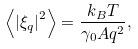Convert formula to latex. <formula><loc_0><loc_0><loc_500><loc_500>\left \langle \left | \xi _ { q } \right | ^ { 2 } \right \rangle = \frac { k _ { B } T } { \gamma _ { 0 } A q ^ { 2 } } ,</formula> 